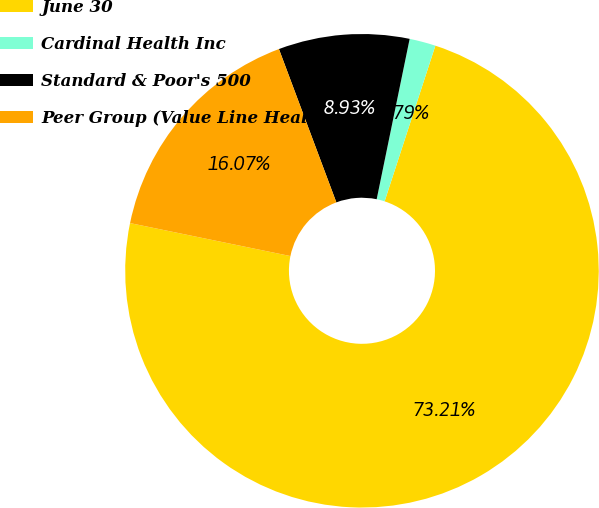<chart> <loc_0><loc_0><loc_500><loc_500><pie_chart><fcel>June 30<fcel>Cardinal Health Inc<fcel>Standard & Poor's 500<fcel>Peer Group (Value Line Health<nl><fcel>73.21%<fcel>1.79%<fcel>8.93%<fcel>16.07%<nl></chart> 